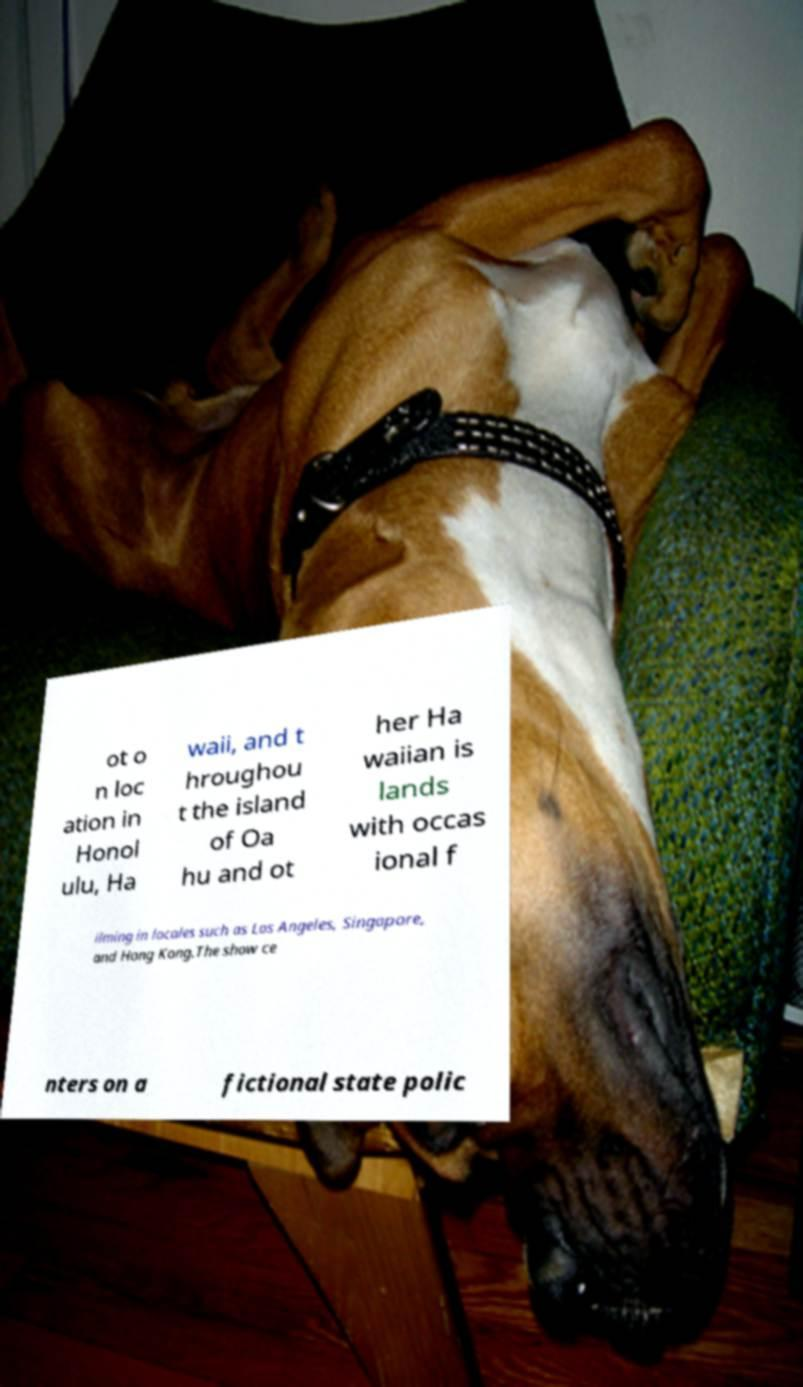Could you extract and type out the text from this image? ot o n loc ation in Honol ulu, Ha waii, and t hroughou t the island of Oa hu and ot her Ha waiian is lands with occas ional f ilming in locales such as Los Angeles, Singapore, and Hong Kong.The show ce nters on a fictional state polic 